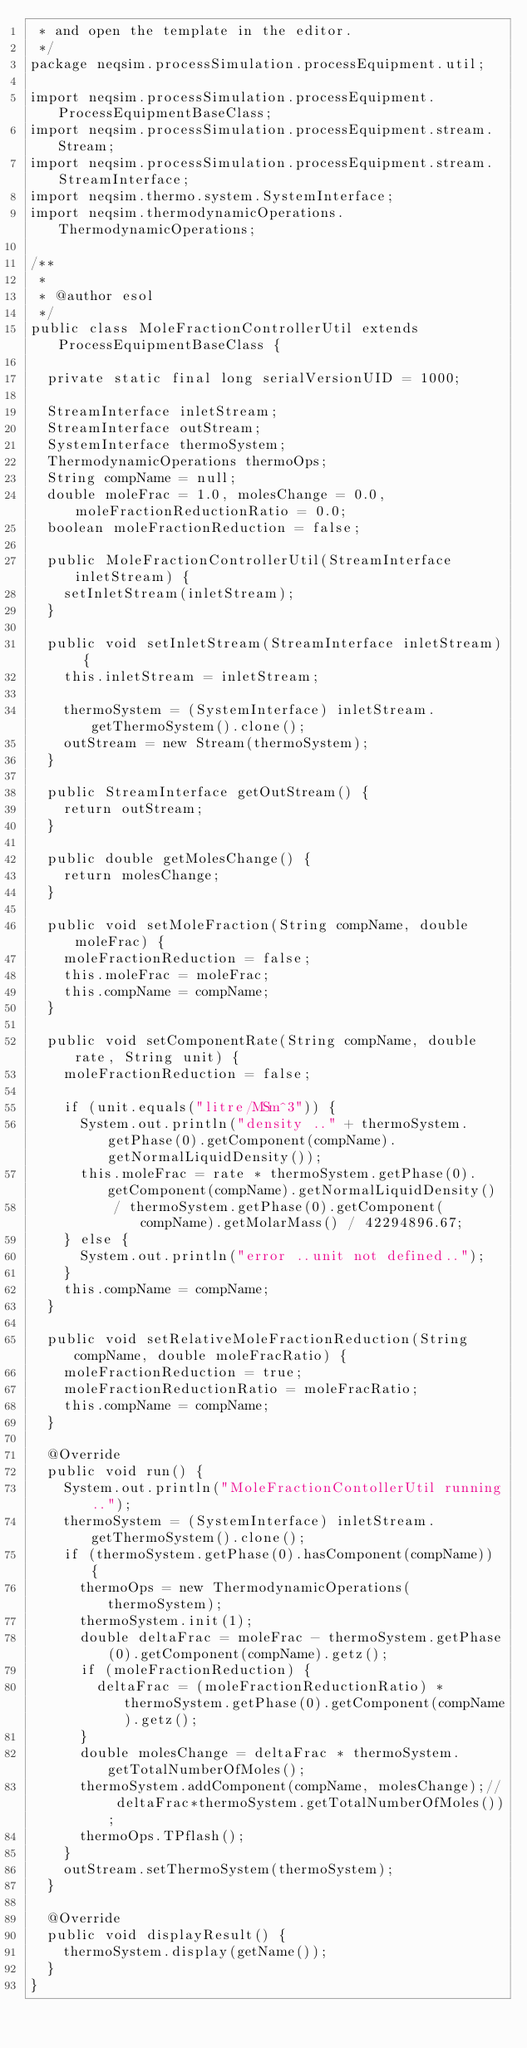Convert code to text. <code><loc_0><loc_0><loc_500><loc_500><_Java_> * and open the template in the editor.
 */
package neqsim.processSimulation.processEquipment.util;

import neqsim.processSimulation.processEquipment.ProcessEquipmentBaseClass;
import neqsim.processSimulation.processEquipment.stream.Stream;
import neqsim.processSimulation.processEquipment.stream.StreamInterface;
import neqsim.thermo.system.SystemInterface;
import neqsim.thermodynamicOperations.ThermodynamicOperations;

/**
 *
 * @author esol
 */
public class MoleFractionControllerUtil extends ProcessEquipmentBaseClass {

	private static final long serialVersionUID = 1000;

	StreamInterface inletStream;
	StreamInterface outStream;
	SystemInterface thermoSystem;
	ThermodynamicOperations thermoOps;
	String compName = null;
	double moleFrac = 1.0, molesChange = 0.0, moleFractionReductionRatio = 0.0;
	boolean moleFractionReduction = false;

	public MoleFractionControllerUtil(StreamInterface inletStream) {
		setInletStream(inletStream);
	}

	public void setInletStream(StreamInterface inletStream) {
		this.inletStream = inletStream;

		thermoSystem = (SystemInterface) inletStream.getThermoSystem().clone();
		outStream = new Stream(thermoSystem);
	}

	public StreamInterface getOutStream() {
		return outStream;
	}

	public double getMolesChange() {
		return molesChange;
	}

	public void setMoleFraction(String compName, double moleFrac) {
		moleFractionReduction = false;
		this.moleFrac = moleFrac;
		this.compName = compName;
	}

	public void setComponentRate(String compName, double rate, String unit) {
		moleFractionReduction = false;

		if (unit.equals("litre/MSm^3")) {
			System.out.println("density .." + thermoSystem.getPhase(0).getComponent(compName).getNormalLiquidDensity());
			this.moleFrac = rate * thermoSystem.getPhase(0).getComponent(compName).getNormalLiquidDensity()
					/ thermoSystem.getPhase(0).getComponent(compName).getMolarMass() / 42294896.67;
		} else {
			System.out.println("error ..unit not defined..");
		}
		this.compName = compName;
	}

	public void setRelativeMoleFractionReduction(String compName, double moleFracRatio) {
		moleFractionReduction = true;
		moleFractionReductionRatio = moleFracRatio;
		this.compName = compName;
	}

	@Override
	public void run() {
		System.out.println("MoleFractionContollerUtil running..");
		thermoSystem = (SystemInterface) inletStream.getThermoSystem().clone();
		if (thermoSystem.getPhase(0).hasComponent(compName)) {
			thermoOps = new ThermodynamicOperations(thermoSystem);
			thermoSystem.init(1);
			double deltaFrac = moleFrac - thermoSystem.getPhase(0).getComponent(compName).getz();
			if (moleFractionReduction) {
				deltaFrac = (moleFractionReductionRatio) * thermoSystem.getPhase(0).getComponent(compName).getz();
			}
			double molesChange = deltaFrac * thermoSystem.getTotalNumberOfMoles();
			thermoSystem.addComponent(compName, molesChange);// deltaFrac*thermoSystem.getTotalNumberOfMoles());
			thermoOps.TPflash();
		}
		outStream.setThermoSystem(thermoSystem);
	}

	@Override
	public void displayResult() {
		thermoSystem.display(getName());
	}
}
</code> 